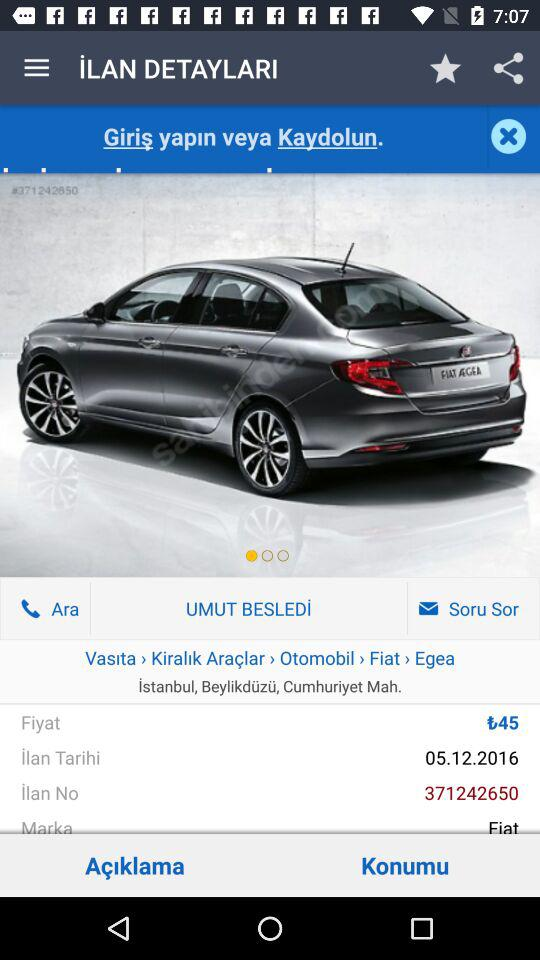What is the name of the person who posted this ad?
Answer the question using a single word or phrase. UMUT BESLEDİ 